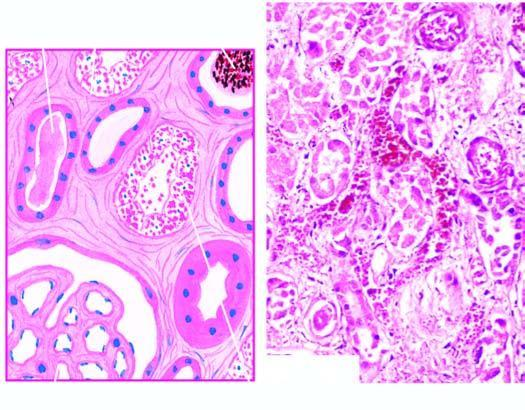whose lumina contain casts?
Answer the question using a single word or phrase. Affected tubules 